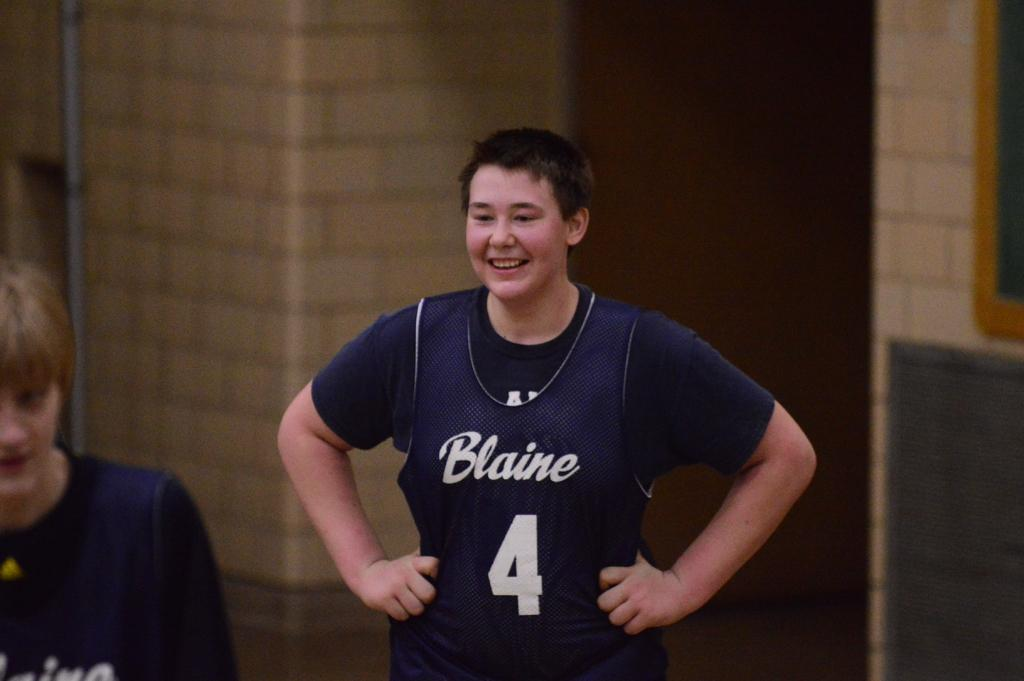<image>
Relay a brief, clear account of the picture shown. A young boy in a dark blue basket ball jersey with the number 4 and the name Blaine on the front is standing in a gym, smiling . 